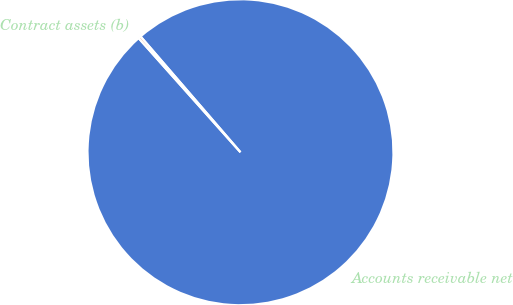Convert chart. <chart><loc_0><loc_0><loc_500><loc_500><pie_chart><fcel>Accounts receivable net<fcel>Contract assets (b)<nl><fcel>99.74%<fcel>0.26%<nl></chart> 